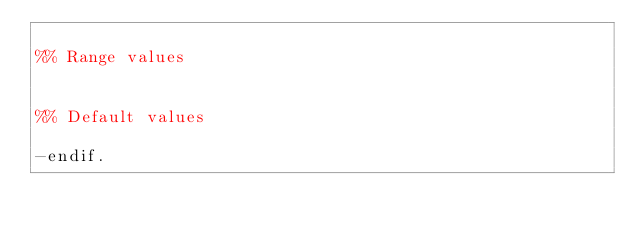Convert code to text. <code><loc_0><loc_0><loc_500><loc_500><_Erlang_>
%% Range values


%% Default values

-endif.
</code> 